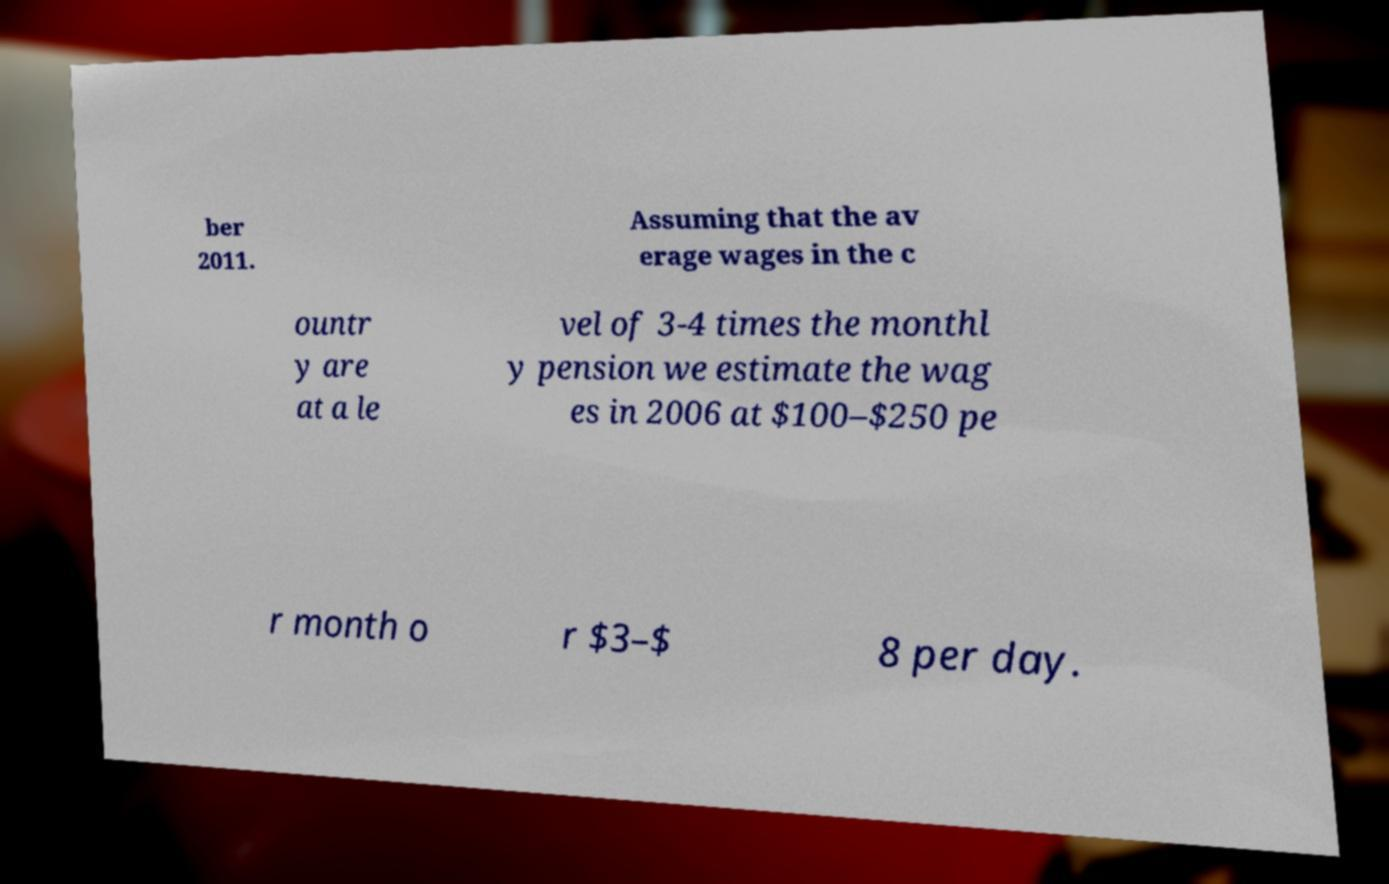Please identify and transcribe the text found in this image. ber 2011. Assuming that the av erage wages in the c ountr y are at a le vel of 3-4 times the monthl y pension we estimate the wag es in 2006 at $100–$250 pe r month o r $3–$ 8 per day. 